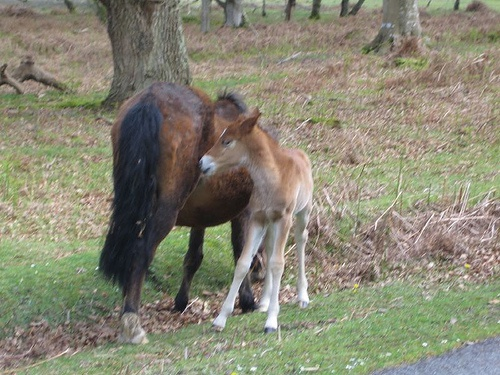Describe the objects in this image and their specific colors. I can see horse in gray and black tones and horse in gray, darkgray, and lightgray tones in this image. 